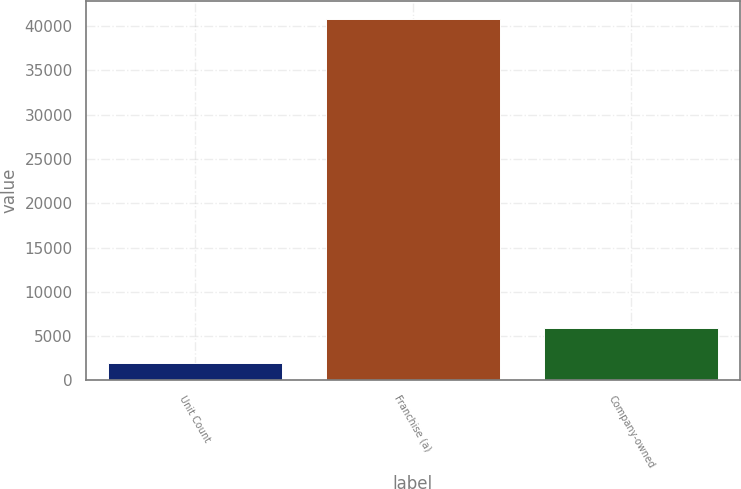Convert chart. <chart><loc_0><loc_0><loc_500><loc_500><bar_chart><fcel>Unit Count<fcel>Franchise (a)<fcel>Company-owned<nl><fcel>2016<fcel>40834<fcel>5897.8<nl></chart> 